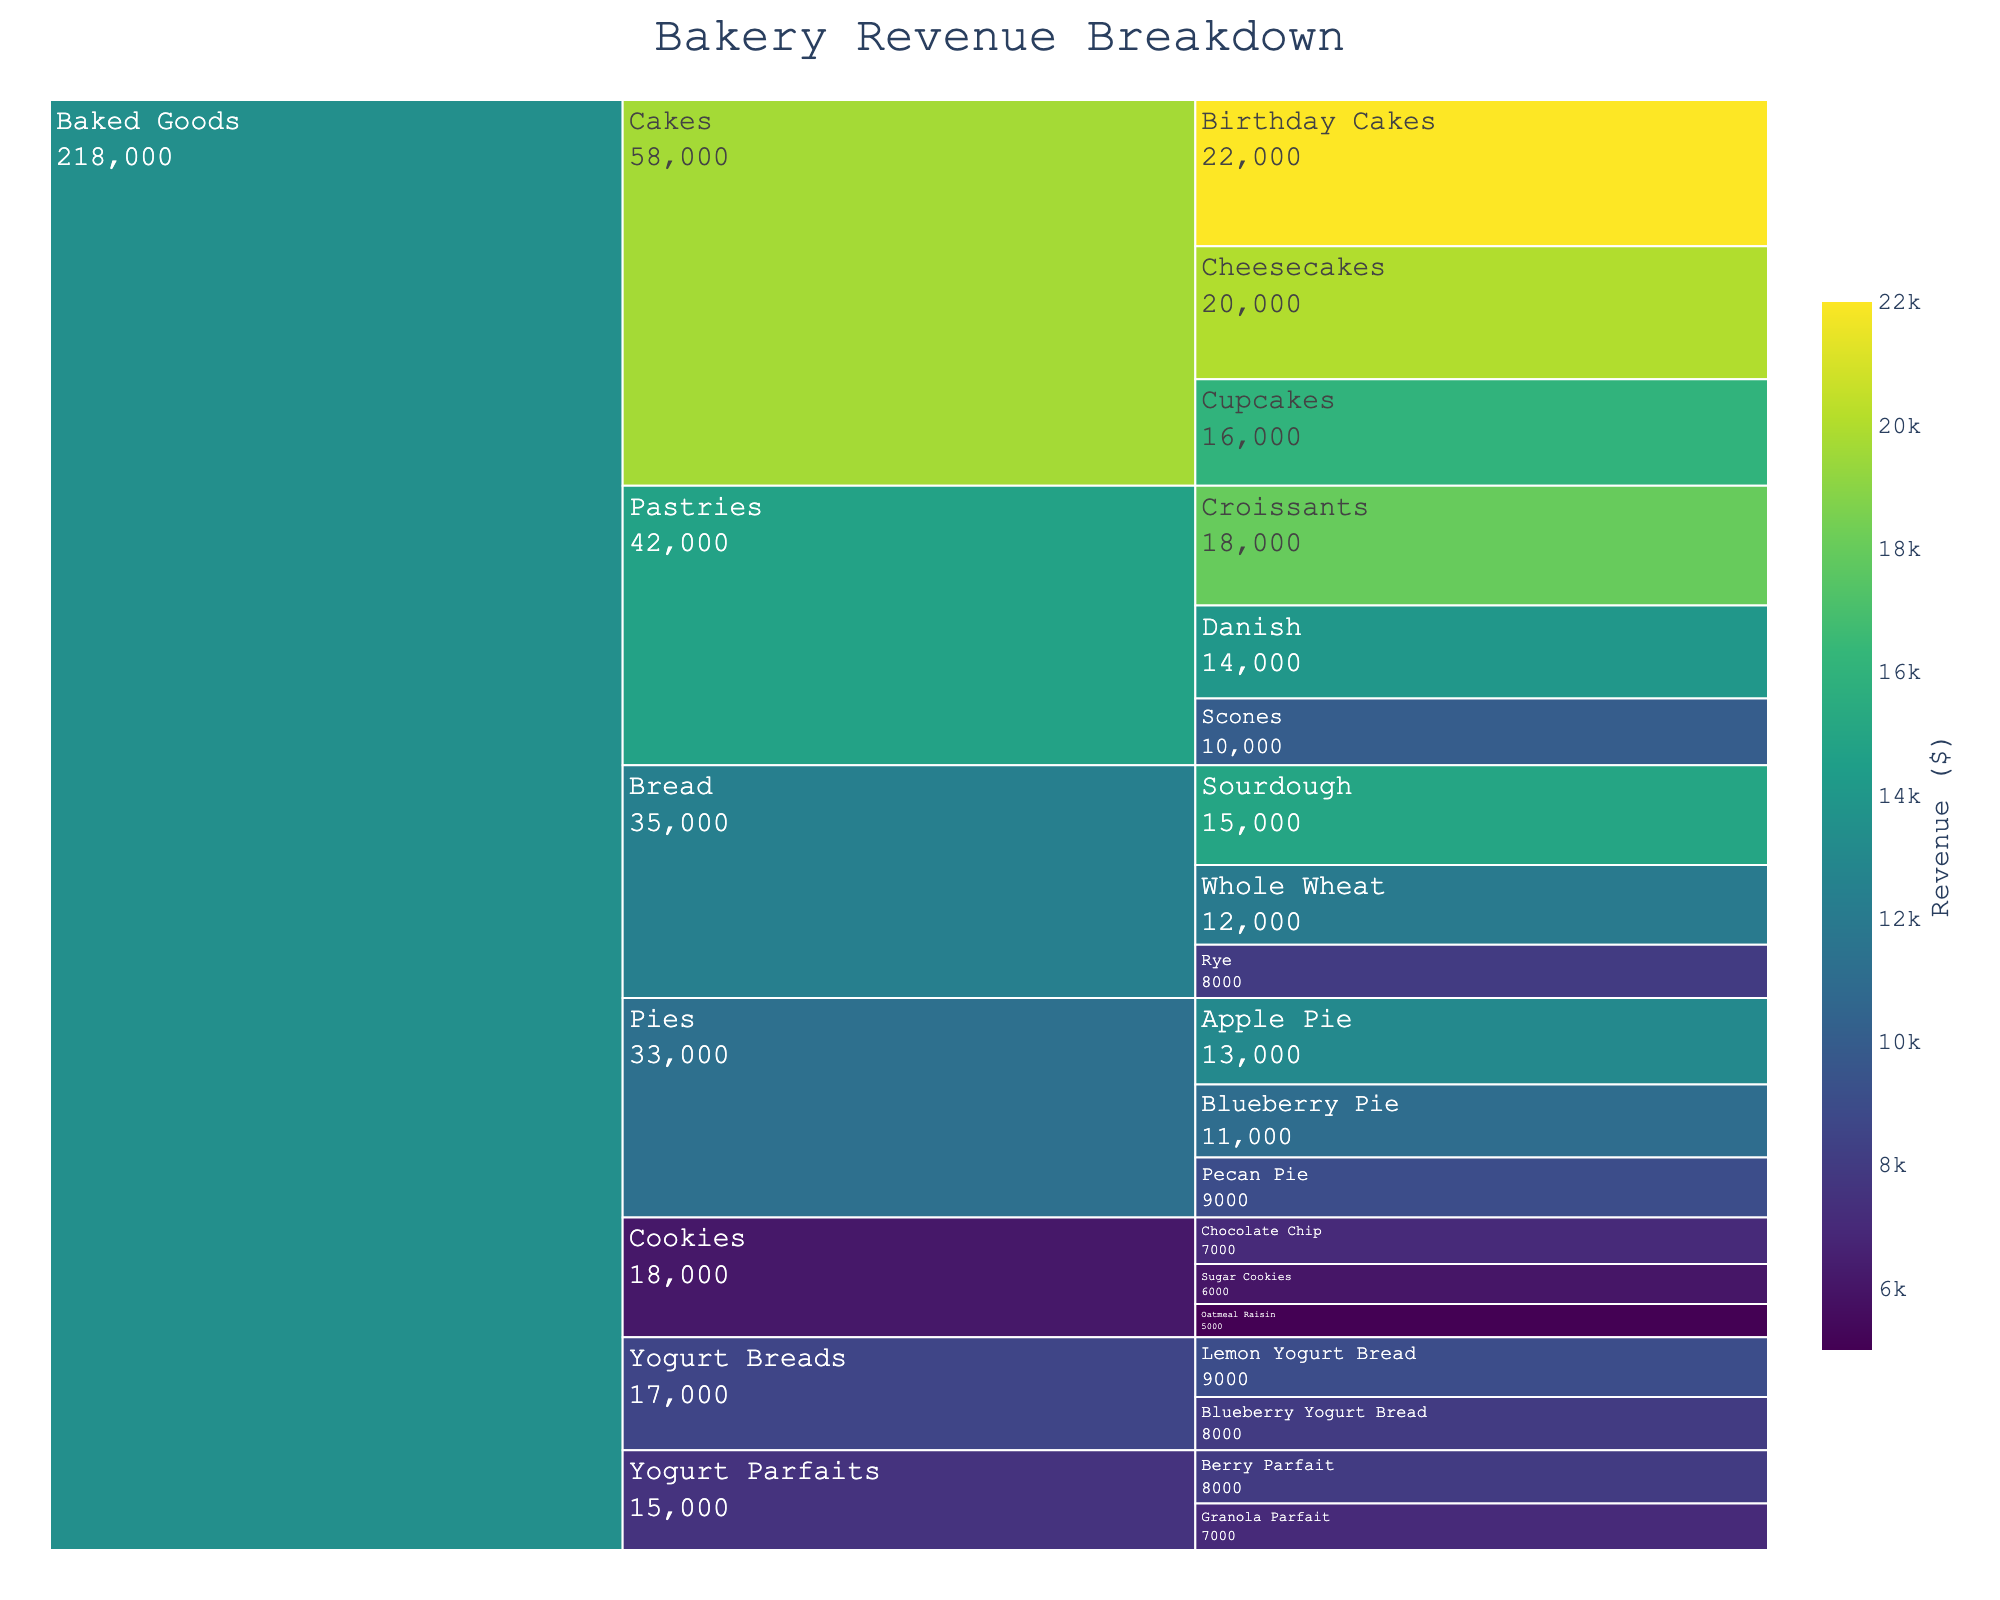What is the title of the figure? The title of the figure is usually located at the top of the chart and summarizes what the figure shows. In this case, the title indicates the figure's purpose.
Answer: Bakery Revenue Breakdown Which subcategory has the highest revenue? Identifying the subcategory with the highest revenue involves looking at the values associated with each subcategory and determining the largest one. The highest value corresponds to the subcategory with the highest revenue.
Answer: Birthday Cakes What is the total revenue from the Pastries category? To find the total revenue for Pastries, sum the revenue from all its subcategories: Croissants, Danish, and Scones. This involves adding 18000, 14000, and 10000.
Answer: $42,000 Compare the revenue of Sourdough bread to Whole Wheat bread. Which is higher, and by how much? Compare the revenue values of Sourdough (15000) and Whole Wheat (12000). Subtract the smaller amount from the larger: 15000 - 12000.
Answer: Sourdough by $3,000 What is the combined revenue of all items under Specialty Items? Sum the revenues of all subcategories under Specialty Items: Berry Parfait (8000), Granola Parfait (7000), Lemon Yogurt Bread (9000), and Blueberry Yogurt Bread (8000). Adding these gives the total revenue.
Answer: $32,000 Which type of pie generates the least revenue? Look at the revenue values for each subcategory under Pies and identify the smallest. Compare the revenues for Apple Pie, Blueberry Pie, and Pecan Pie.
Answer: Pecan Pie Is the revenue from Cheesecakes greater than the total revenue from Cookies? First, sum the revenue from all cookies: Chocolate Chip (7000) + Oatmeal Raisin (5000) + Sugar Cookies (6000) = 18000. Compare this sum to the revenue from Cheesecakes (20000).
Answer: Yes How much more revenue do Cakes generate compared to Bread? Calculate the total revenue for Cakes: Birthday Cakes (22000) + Cupcakes (16000) + Cheesecakes (20000) = 58000 and for Bread: Sourdough (15000) + Whole Wheat (12000) + Rye (8000) = 35000. Subtract the Bread total from the Cakes total.
Answer: $23,000 What's the average revenue of the subcategories under the category Pies? Sum the revenues for Apple Pie (13000), Blueberry Pie (11000), and Pecan Pie (9000), and divide by the number of subcategories (3): (13000 + 11000 + 9000) / 3 = 11000.
Answer: $11,000 Explain the distribution of revenue within the Baked Goods category. Identify the revenue values for each subcategory within Bread, Pastries, Cakes, Pies, and Cookies. Sum the values within each category and describe their relative proportions and highest earners.
Answer: Breads, Pastries, Cakes, Pies, and Cookies have varied revenues, with Cakes earning the most 